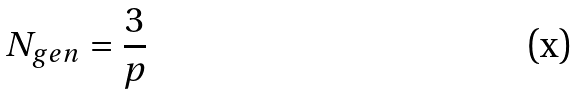Convert formula to latex. <formula><loc_0><loc_0><loc_500><loc_500>N _ { g e n } = \frac { 3 } { p }</formula> 